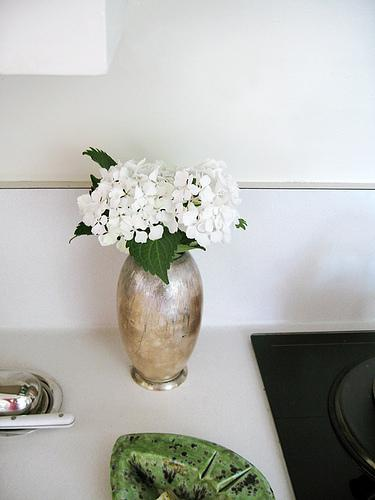Question: what color is the vase?
Choices:
A. Black.
B. White.
C. Pink.
D. Pewter.
Answer with the letter. Answer: D Question: who arranged the flowers?
Choices:
A. A talented arranger.
B. My mother-in-law.
C. My maid.
D. My husband.
Answer with the letter. Answer: A 